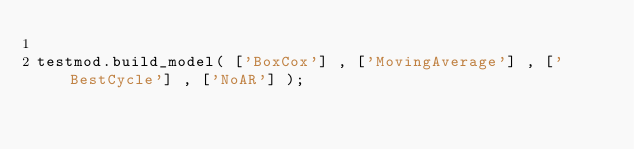Convert code to text. <code><loc_0><loc_0><loc_500><loc_500><_Python_>
testmod.build_model( ['BoxCox'] , ['MovingAverage'] , ['BestCycle'] , ['NoAR'] );</code> 